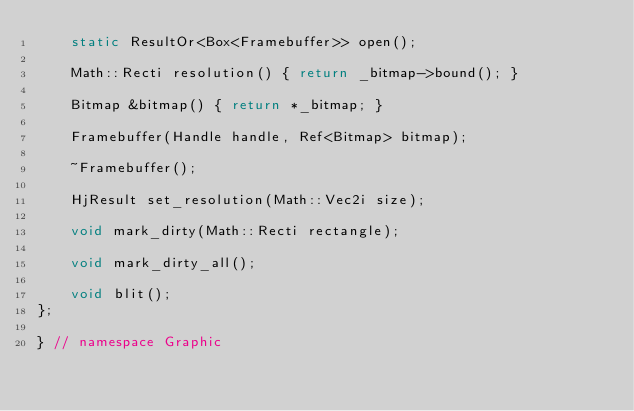Convert code to text. <code><loc_0><loc_0><loc_500><loc_500><_C_>    static ResultOr<Box<Framebuffer>> open();

    Math::Recti resolution() { return _bitmap->bound(); }

    Bitmap &bitmap() { return *_bitmap; }

    Framebuffer(Handle handle, Ref<Bitmap> bitmap);

    ~Framebuffer();

    HjResult set_resolution(Math::Vec2i size);

    void mark_dirty(Math::Recti rectangle);

    void mark_dirty_all();

    void blit();
};

} // namespace Graphic
</code> 